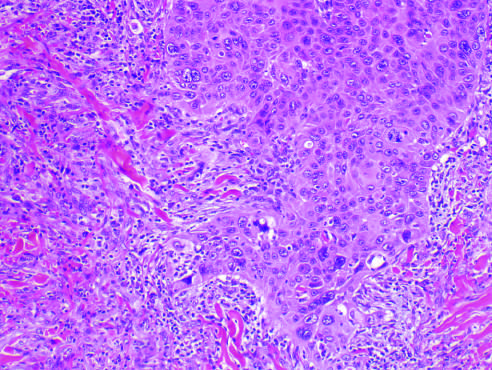what does the tumor invade?
Answer the question using a single word or phrase. The dermal soft tissue as irregular projections of atypical squamous cells exhibiting acantholysis 